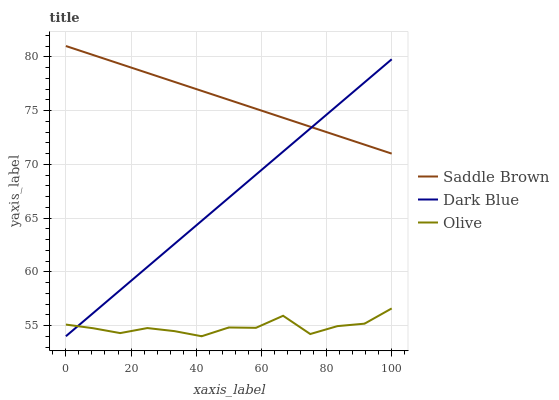Does Olive have the minimum area under the curve?
Answer yes or no. Yes. Does Saddle Brown have the maximum area under the curve?
Answer yes or no. Yes. Does Dark Blue have the minimum area under the curve?
Answer yes or no. No. Does Dark Blue have the maximum area under the curve?
Answer yes or no. No. Is Dark Blue the smoothest?
Answer yes or no. Yes. Is Olive the roughest?
Answer yes or no. Yes. Is Saddle Brown the smoothest?
Answer yes or no. No. Is Saddle Brown the roughest?
Answer yes or no. No. Does Olive have the lowest value?
Answer yes or no. Yes. Does Saddle Brown have the lowest value?
Answer yes or no. No. Does Saddle Brown have the highest value?
Answer yes or no. Yes. Does Dark Blue have the highest value?
Answer yes or no. No. Is Olive less than Saddle Brown?
Answer yes or no. Yes. Is Saddle Brown greater than Olive?
Answer yes or no. Yes. Does Olive intersect Dark Blue?
Answer yes or no. Yes. Is Olive less than Dark Blue?
Answer yes or no. No. Is Olive greater than Dark Blue?
Answer yes or no. No. Does Olive intersect Saddle Brown?
Answer yes or no. No. 